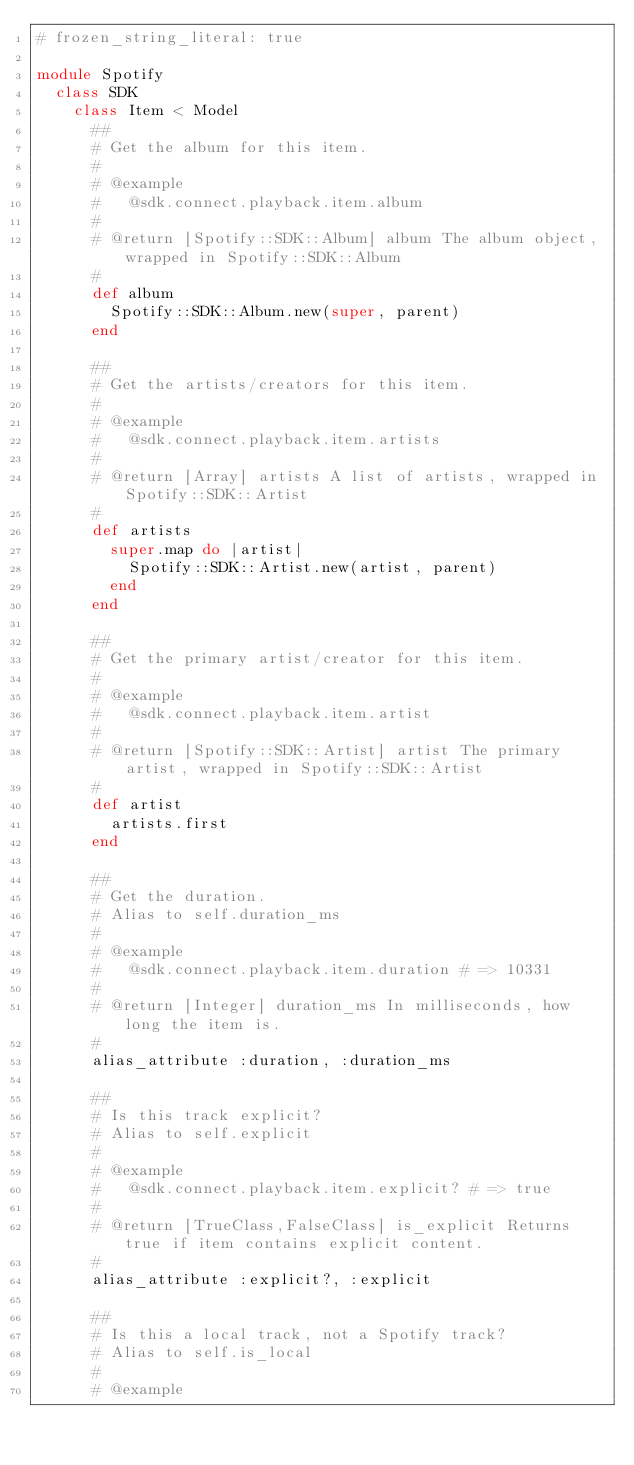Convert code to text. <code><loc_0><loc_0><loc_500><loc_500><_Ruby_># frozen_string_literal: true

module Spotify
  class SDK
    class Item < Model
      ##
      # Get the album for this item.
      #
      # @example
      #   @sdk.connect.playback.item.album
      #
      # @return [Spotify::SDK::Album] album The album object, wrapped in Spotify::SDK::Album
      #
      def album
        Spotify::SDK::Album.new(super, parent)
      end

      ##
      # Get the artists/creators for this item.
      #
      # @example
      #   @sdk.connect.playback.item.artists
      #
      # @return [Array] artists A list of artists, wrapped in Spotify::SDK::Artist
      #
      def artists
        super.map do |artist|
          Spotify::SDK::Artist.new(artist, parent)
        end
      end

      ##
      # Get the primary artist/creator for this item.
      #
      # @example
      #   @sdk.connect.playback.item.artist
      #
      # @return [Spotify::SDK::Artist] artist The primary artist, wrapped in Spotify::SDK::Artist
      #
      def artist
        artists.first
      end

      ##
      # Get the duration.
      # Alias to self.duration_ms
      #
      # @example
      #   @sdk.connect.playback.item.duration # => 10331
      #
      # @return [Integer] duration_ms In milliseconds, how long the item is.
      #
      alias_attribute :duration, :duration_ms

      ##
      # Is this track explicit?
      # Alias to self.explicit
      #
      # @example
      #   @sdk.connect.playback.item.explicit? # => true
      #
      # @return [TrueClass,FalseClass] is_explicit Returns true if item contains explicit content.
      #
      alias_attribute :explicit?, :explicit

      ##
      # Is this a local track, not a Spotify track?
      # Alias to self.is_local
      #
      # @example</code> 